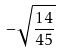<formula> <loc_0><loc_0><loc_500><loc_500>- \sqrt { \frac { 1 4 } { 4 5 } }</formula> 